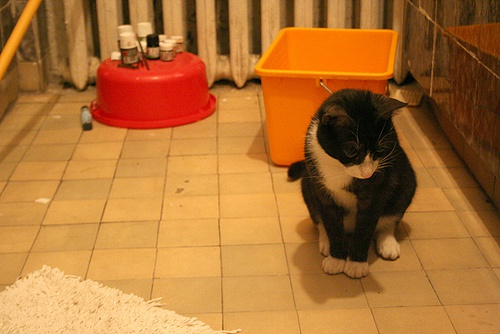Describe the objects in this image and their specific colors. I can see cat in maroon, black, and olive tones and bowl in maroon, red, and brown tones in this image. 